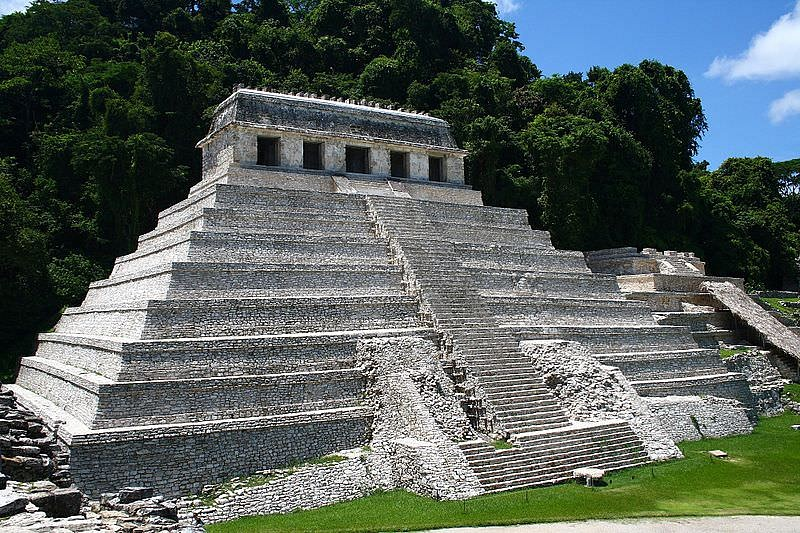Can you describe the architectural design and significance of the pyramid? The architectural design of the Temple of the Inscriptions is a remarkable feat of ancient engineering. The pyramid encompasses multiple tiers or levels, each meticulously constructed with finely cut stones, creating a visually harmonious and balanced structure. The steepness of the steps, which lead to the temple at the apex, adds to the grandeur and sense of ascension associated with the edifice. The temple at the top is distinct with its white walls and red roof, serving as a stark contrast against the gray stone of the pyramid and the dense green backdrop. This design not only emphasizes verticality and reaches towards the heavens but also incorporates Mayan architectural principles that symbolize their spiritual beliefs and societal hierarchy. The pyramid serves as a testament to the Mayans' advanced knowledge in engineering, astronomy, and religious symbolism, marking it as a significant cultural and historical landmark. What would it be like to stand at the top of this pyramid today? Standing at the top of the Temple of the Inscriptions today would be an awe-inspiring experience. The sheer height of the pyramid would provide a commanding view over the ancient city of Palenque and the surrounding jungle. The lush greenery, extending as far as the eye can see, would create a breathtaking panorama, merging the remnants of a once-thriving civilization with the natural beauty of the landscape. The sense of history would be palpable, with every stone step reflecting centuries of culture, spirituality, and human achievement. The tranquility and serene atmosphere at the summit would contrast sharply with the bustling life that once animated this place, offering a unique moment of connection between the past and present. 